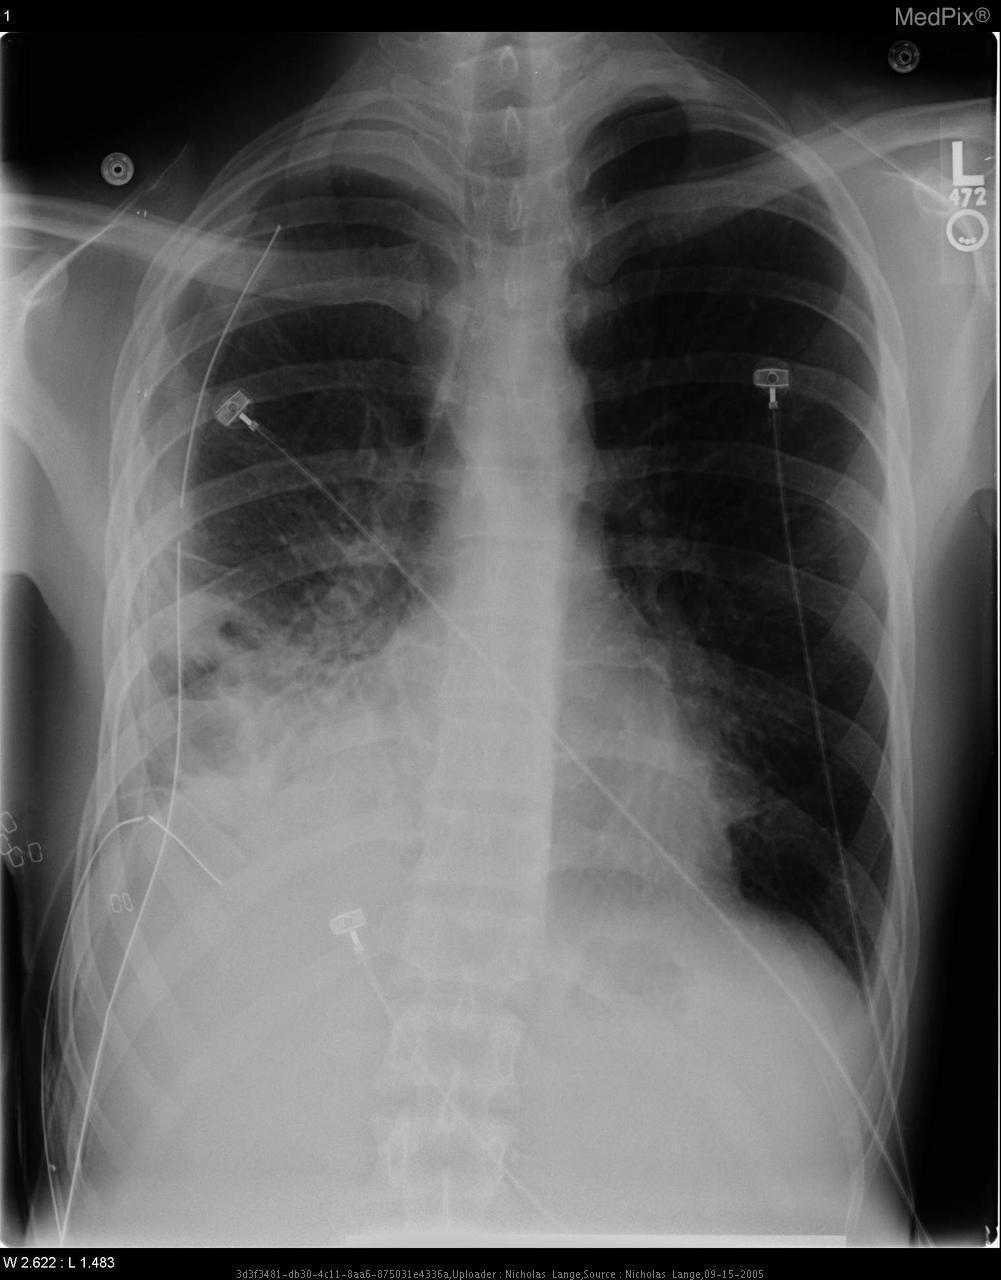Is the stomach visualized here?
Quick response, please. No. Are the lines seen on the exterior or interior of the patient?
Answer briefly. Exterior. Are the lines in the image inside or outside of the patient?
Quick response, please. Outside. What indicates there is a consolidation in the right lung?
Keep it brief. Blunting of the costophrenic angle, loss of the right hemidiaphragm and right heart border. What is the observed sign of pulmonary consolidation on the right side?
Short answer required. Blunting of the costophrenic angle, loss of the right hemidiaphragm and right heart border. Are the clavicles fractured?
Concise answer only. No. Is a clavicular fracture present?
Concise answer only. No. 